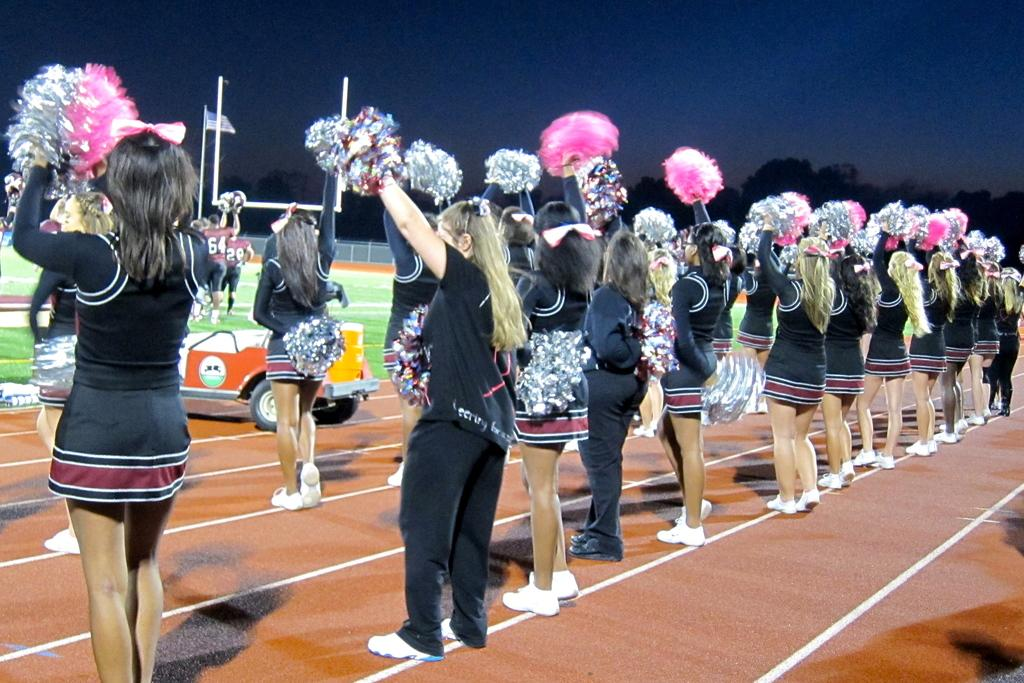What are the people in the image holding? The people in the image are holding pom poms. What can be seen in the background of the image? There are poles, trees, and sky visible in the background of the image. What is the purpose of the flag in the image? The purpose of the flag in the image is not specified, but it may represent a team, organization, or country. What type of vehicle is present in the image? There is a vehicle in the image, but its specific type is not mentioned. Where is the zoo located in the image? There is no zoo present in the image. What type of recess activity are the people participating in with their pom poms? The image does not provide enough information to determine if the people are participating in a recess activity or any specific activity involving pom poms. 